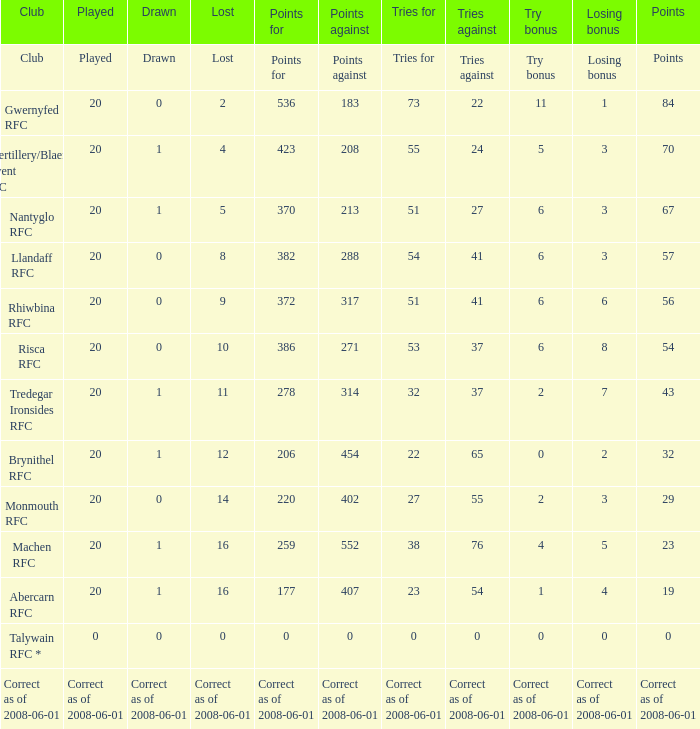What club had 56 points? Rhiwbina RFC. 